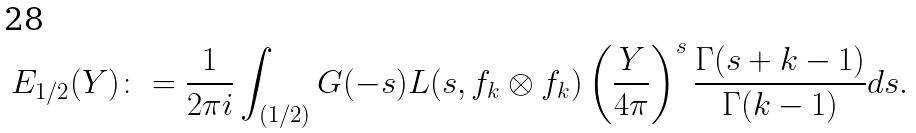Convert formula to latex. <formula><loc_0><loc_0><loc_500><loc_500>E _ { 1 / 2 } ( Y ) \colon = \frac { 1 } { 2 \pi i } \int _ { ( 1 / 2 ) } G ( - s ) L ( s , f _ { k } \otimes f _ { k } ) \left ( \frac { Y } { 4 \pi } \right ) ^ { s } \frac { \Gamma ( s + k - 1 ) } { \Gamma ( k - 1 ) } d s .</formula> 